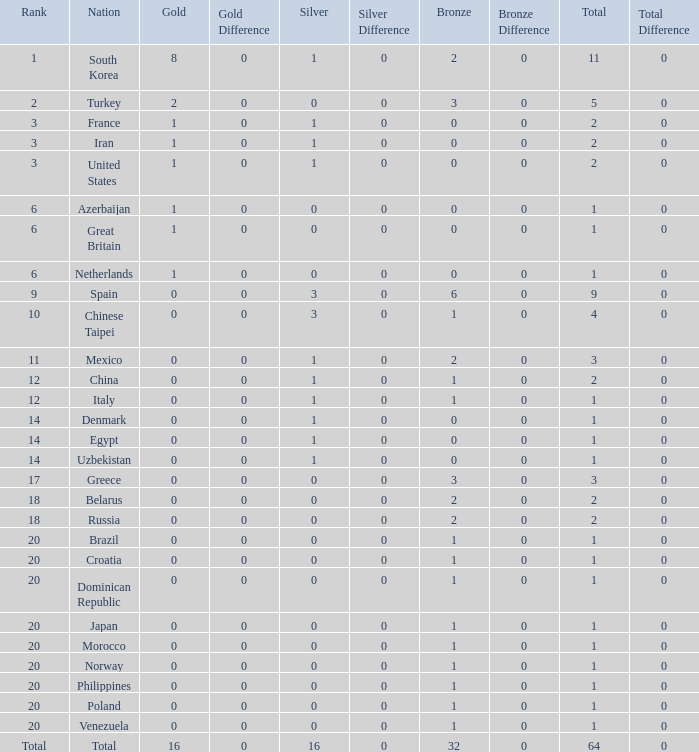How many total silvers does Russia have? 1.0. 